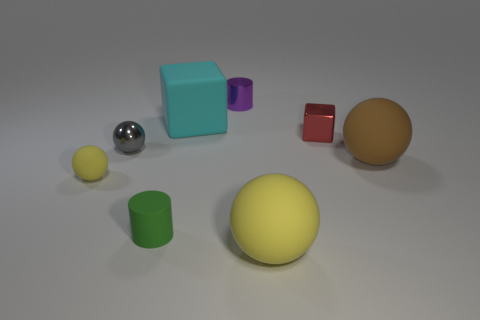Add 2 large green balls. How many objects exist? 10 Subtract all cubes. How many objects are left? 6 Add 8 tiny purple shiny objects. How many tiny purple shiny objects are left? 9 Add 3 small purple metal cylinders. How many small purple metal cylinders exist? 4 Subtract 0 purple blocks. How many objects are left? 8 Subtract all large cubes. Subtract all tiny green rubber cylinders. How many objects are left? 6 